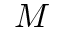Convert formula to latex. <formula><loc_0><loc_0><loc_500><loc_500>M</formula> 